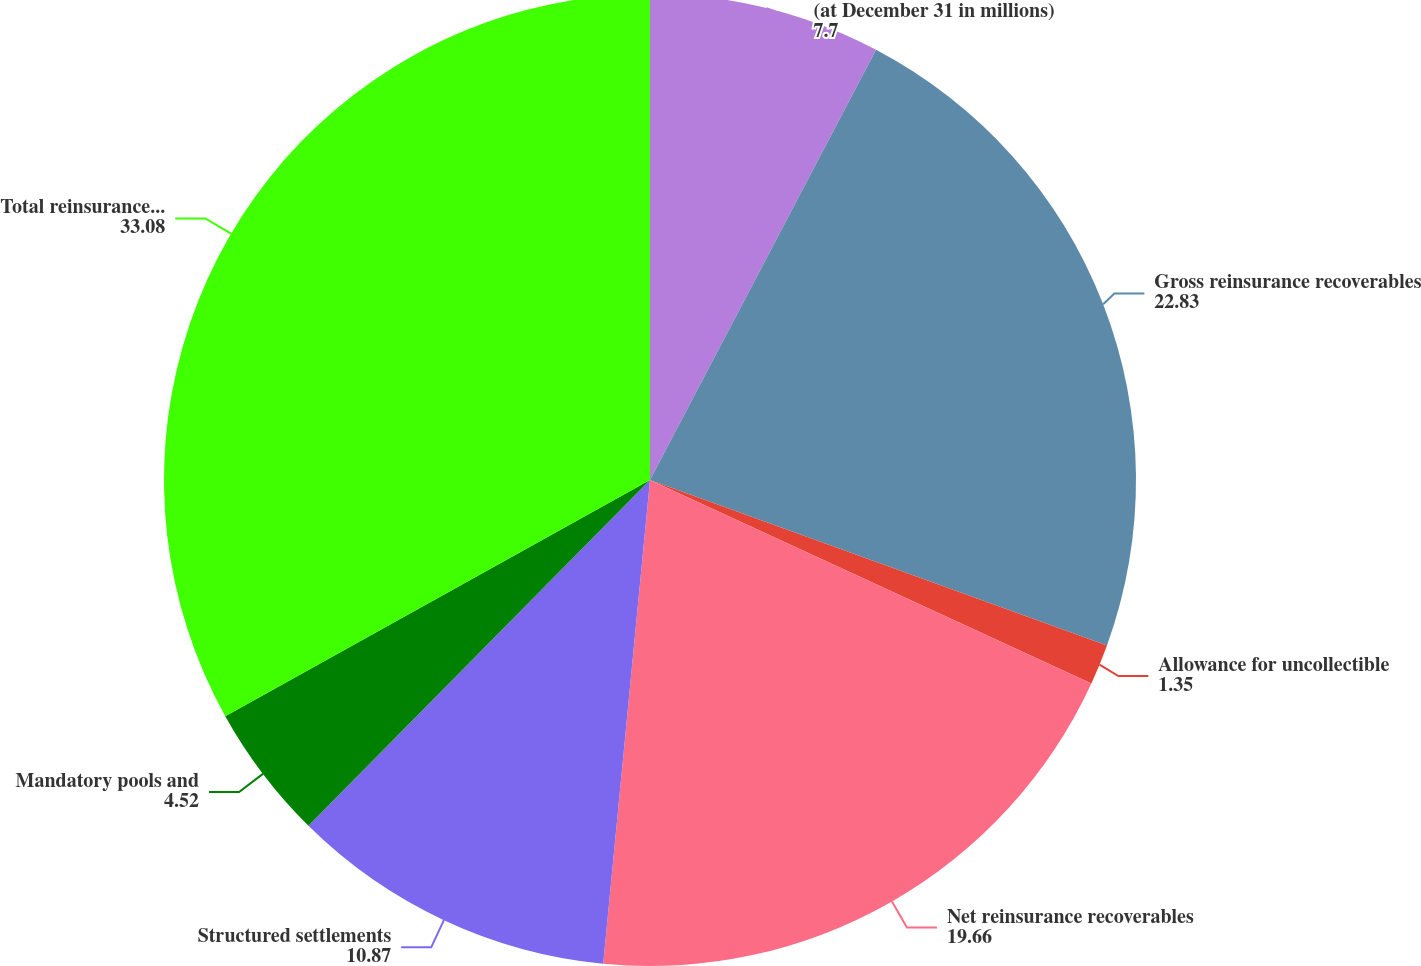Convert chart to OTSL. <chart><loc_0><loc_0><loc_500><loc_500><pie_chart><fcel>(at December 31 in millions)<fcel>Gross reinsurance recoverables<fcel>Allowance for uncollectible<fcel>Net reinsurance recoverables<fcel>Structured settlements<fcel>Mandatory pools and<fcel>Total reinsurance recoverables<nl><fcel>7.7%<fcel>22.83%<fcel>1.35%<fcel>19.66%<fcel>10.87%<fcel>4.52%<fcel>33.08%<nl></chart> 